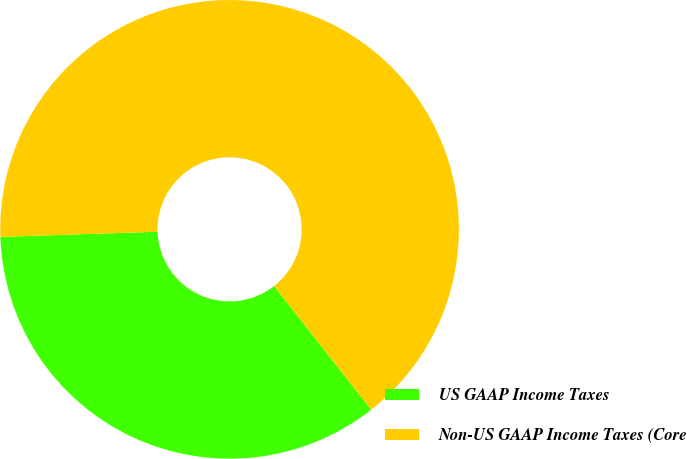Convert chart. <chart><loc_0><loc_0><loc_500><loc_500><pie_chart><fcel>US GAAP Income Taxes<fcel>Non-US GAAP Income Taxes (Core<nl><fcel>35.07%<fcel>64.93%<nl></chart> 